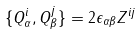Convert formula to latex. <formula><loc_0><loc_0><loc_500><loc_500>\{ Q _ { \alpha } ^ { i } , Q _ { \beta } ^ { j } \} = 2 \epsilon _ { \alpha \beta } Z ^ { i j }</formula> 